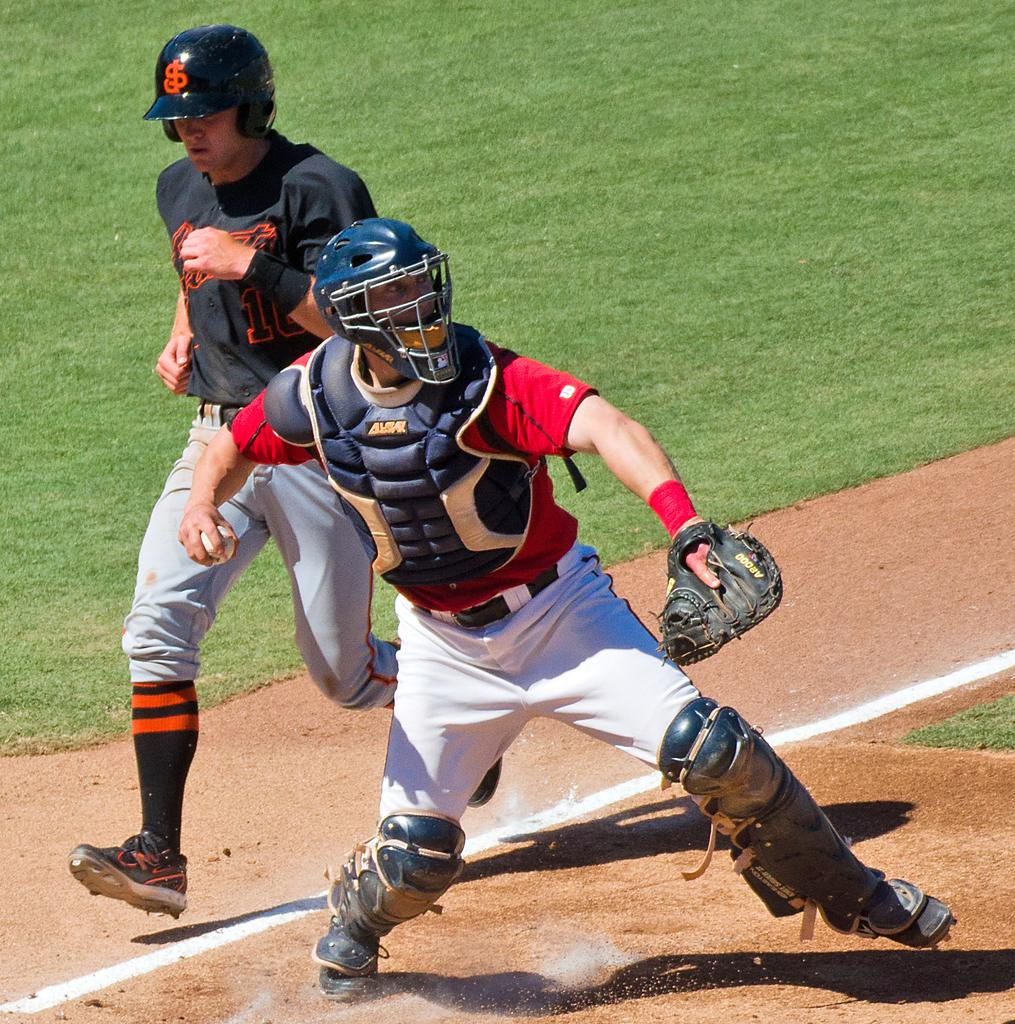What is the man in the image wearing on his hands? The man is wearing gloves in the image. What is the man wearing on his head? The man is wearing a helmet in the image. What is the man holding in the image? The man is holding a ball in the image. Can you describe the other person in the image? The other person in the image is running and wearing a helmet. How many goldfish are swimming in the background of the image? There are no goldfish present in the image. What is the man doing to increase the size of the ball in the image? The man is not doing anything to increase the size of the ball in the image; he is simply holding it. 